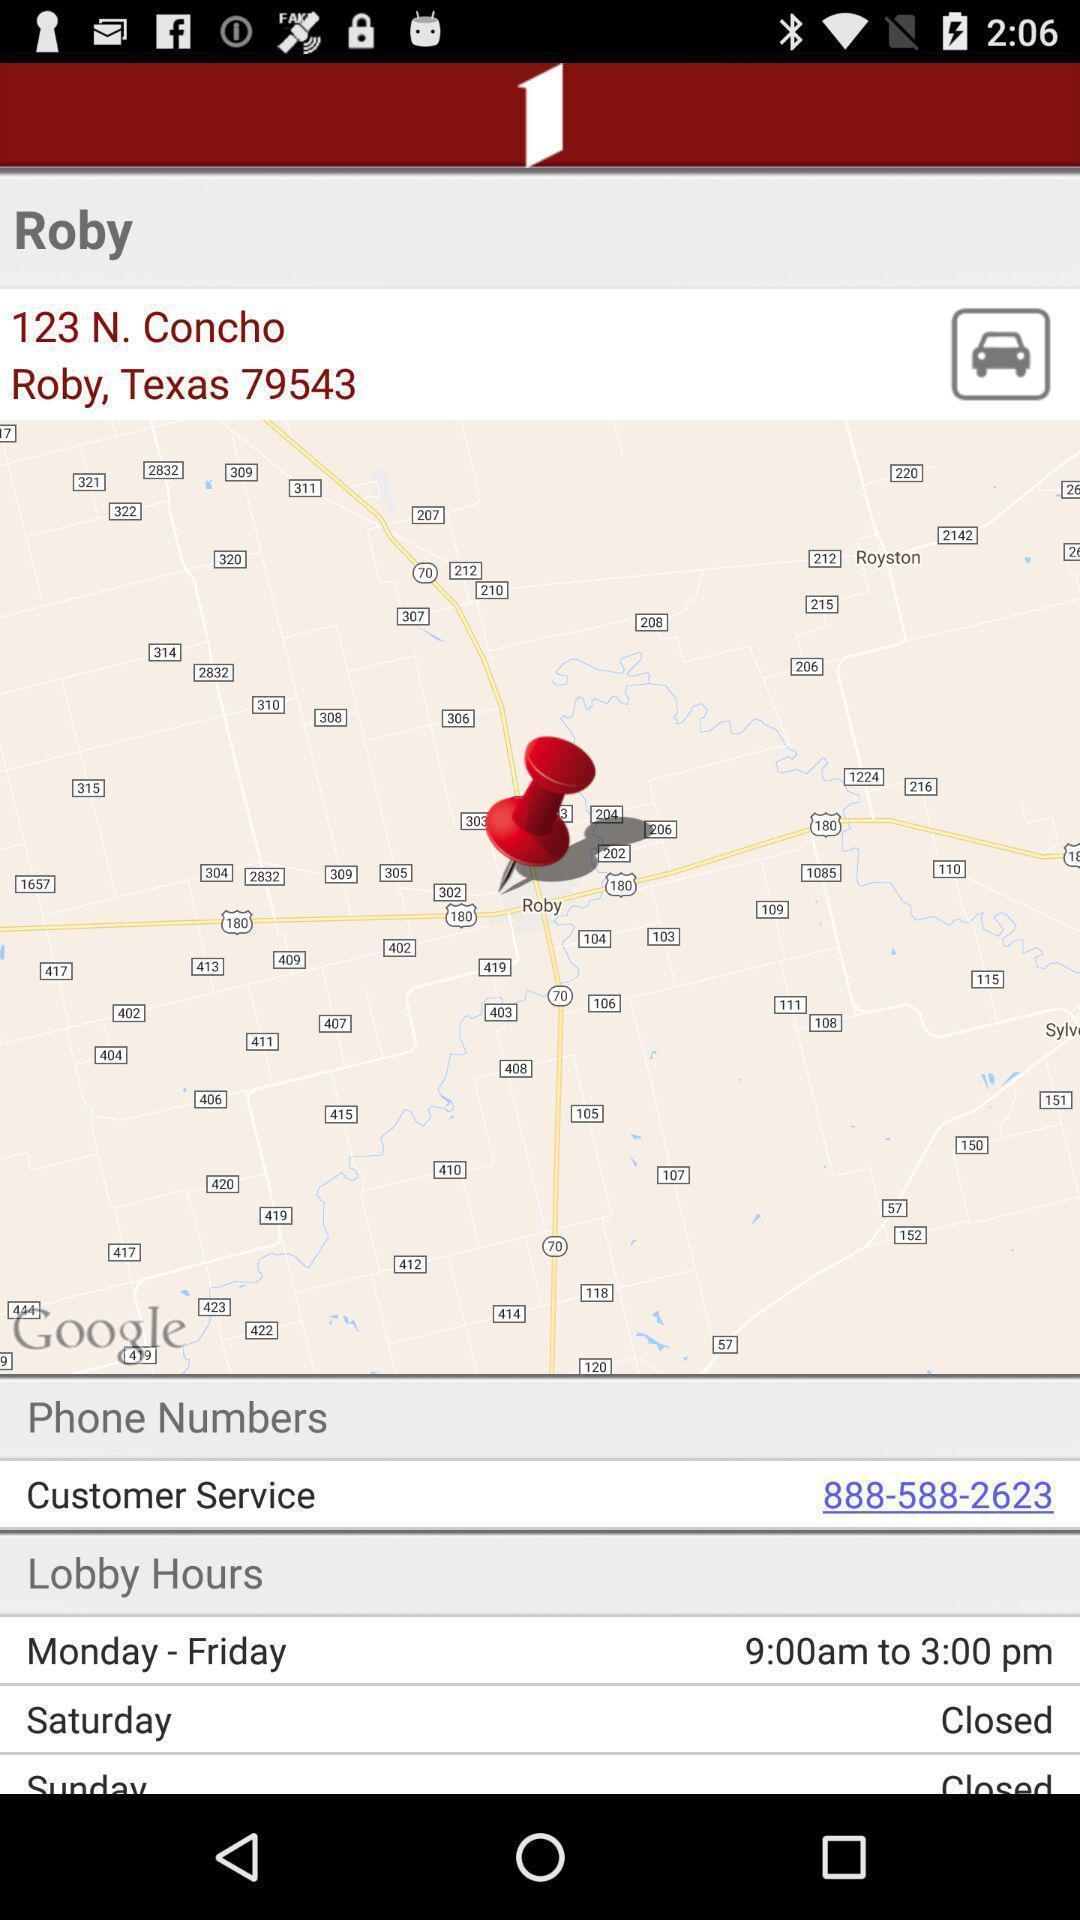Provide a textual representation of this image. Page displaying a pinned address in navigation application. 